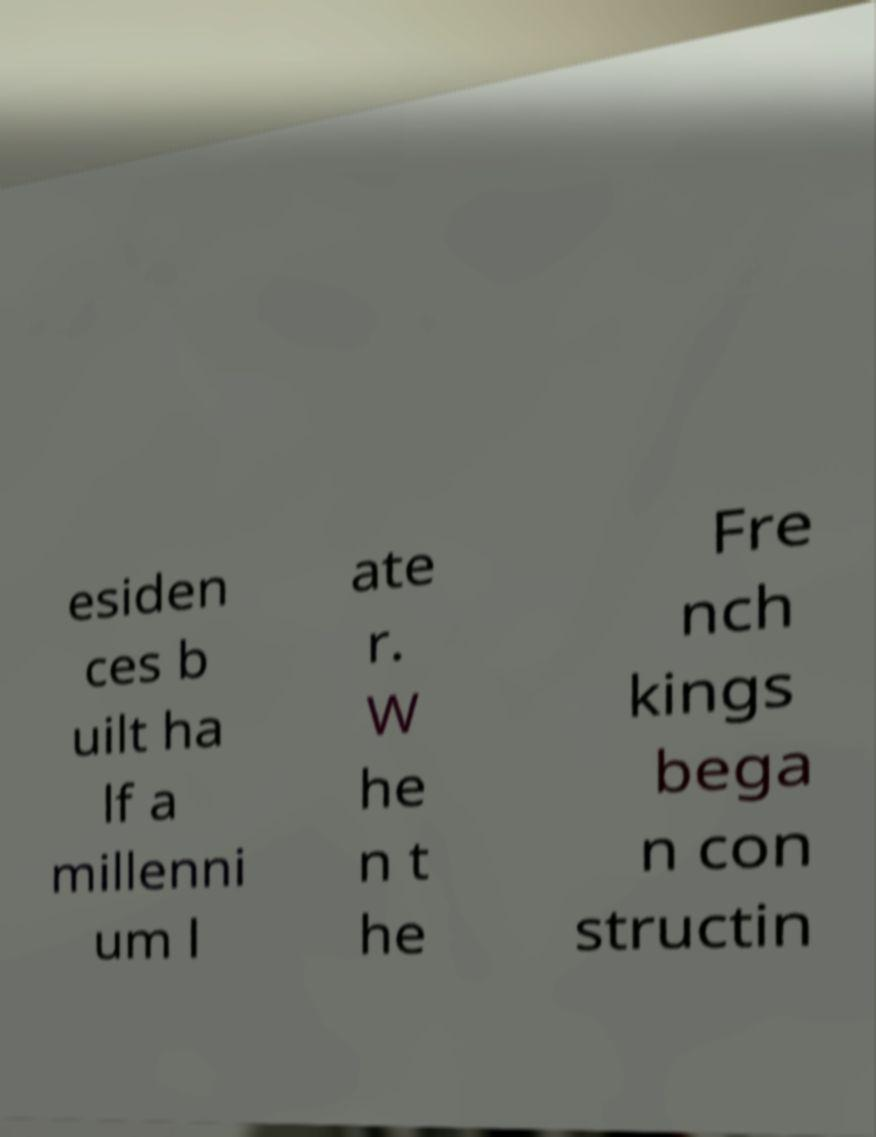Please identify and transcribe the text found in this image. esiden ces b uilt ha lf a millenni um l ate r. W he n t he Fre nch kings bega n con structin 